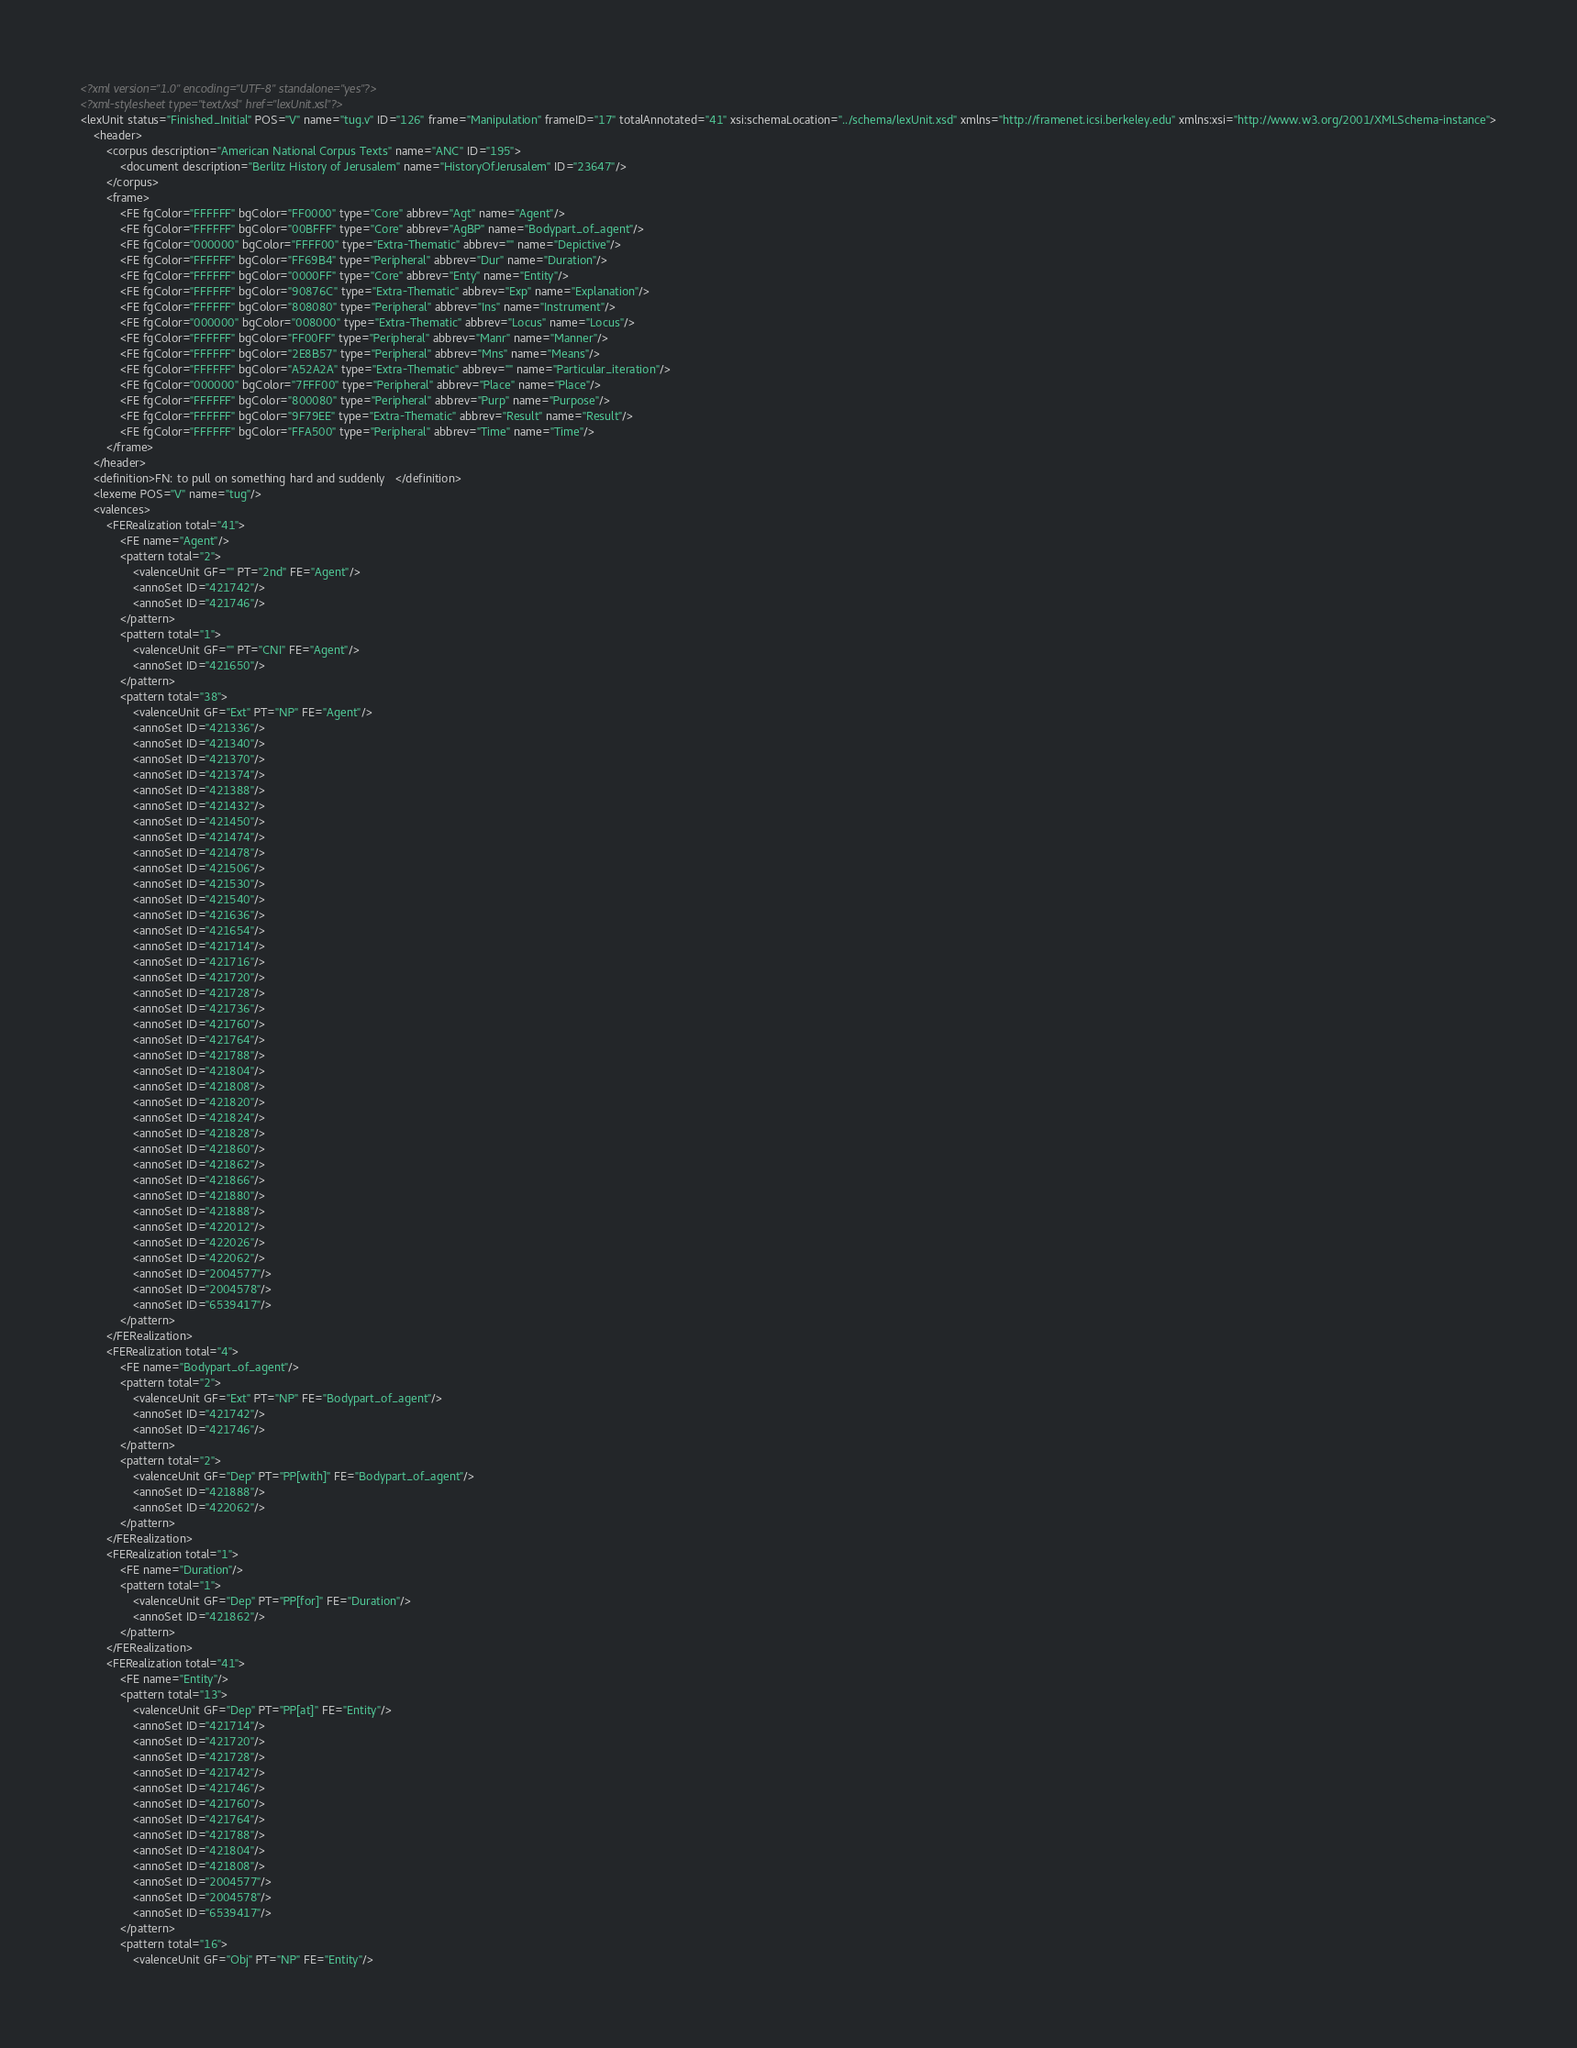Convert code to text. <code><loc_0><loc_0><loc_500><loc_500><_XML_><?xml version="1.0" encoding="UTF-8" standalone="yes"?>
<?xml-stylesheet type="text/xsl" href="lexUnit.xsl"?>
<lexUnit status="Finished_Initial" POS="V" name="tug.v" ID="126" frame="Manipulation" frameID="17" totalAnnotated="41" xsi:schemaLocation="../schema/lexUnit.xsd" xmlns="http://framenet.icsi.berkeley.edu" xmlns:xsi="http://www.w3.org/2001/XMLSchema-instance">
    <header>
        <corpus description="American National Corpus Texts" name="ANC" ID="195">
            <document description="Berlitz History of Jerusalem" name="HistoryOfJerusalem" ID="23647"/>
        </corpus>
        <frame>
            <FE fgColor="FFFFFF" bgColor="FF0000" type="Core" abbrev="Agt" name="Agent"/>
            <FE fgColor="FFFFFF" bgColor="00BFFF" type="Core" abbrev="AgBP" name="Bodypart_of_agent"/>
            <FE fgColor="000000" bgColor="FFFF00" type="Extra-Thematic" abbrev="" name="Depictive"/>
            <FE fgColor="FFFFFF" bgColor="FF69B4" type="Peripheral" abbrev="Dur" name="Duration"/>
            <FE fgColor="FFFFFF" bgColor="0000FF" type="Core" abbrev="Enty" name="Entity"/>
            <FE fgColor="FFFFFF" bgColor="90876C" type="Extra-Thematic" abbrev="Exp" name="Explanation"/>
            <FE fgColor="FFFFFF" bgColor="808080" type="Peripheral" abbrev="Ins" name="Instrument"/>
            <FE fgColor="000000" bgColor="008000" type="Extra-Thematic" abbrev="Locus" name="Locus"/>
            <FE fgColor="FFFFFF" bgColor="FF00FF" type="Peripheral" abbrev="Manr" name="Manner"/>
            <FE fgColor="FFFFFF" bgColor="2E8B57" type="Peripheral" abbrev="Mns" name="Means"/>
            <FE fgColor="FFFFFF" bgColor="A52A2A" type="Extra-Thematic" abbrev="" name="Particular_iteration"/>
            <FE fgColor="000000" bgColor="7FFF00" type="Peripheral" abbrev="Place" name="Place"/>
            <FE fgColor="FFFFFF" bgColor="800080" type="Peripheral" abbrev="Purp" name="Purpose"/>
            <FE fgColor="FFFFFF" bgColor="9F79EE" type="Extra-Thematic" abbrev="Result" name="Result"/>
            <FE fgColor="FFFFFF" bgColor="FFA500" type="Peripheral" abbrev="Time" name="Time"/>
        </frame>
    </header>
    <definition>FN: to pull on something hard and suddenly   </definition>
    <lexeme POS="V" name="tug"/>
    <valences>
        <FERealization total="41">
            <FE name="Agent"/>
            <pattern total="2">
                <valenceUnit GF="" PT="2nd" FE="Agent"/>
                <annoSet ID="421742"/>
                <annoSet ID="421746"/>
            </pattern>
            <pattern total="1">
                <valenceUnit GF="" PT="CNI" FE="Agent"/>
                <annoSet ID="421650"/>
            </pattern>
            <pattern total="38">
                <valenceUnit GF="Ext" PT="NP" FE="Agent"/>
                <annoSet ID="421336"/>
                <annoSet ID="421340"/>
                <annoSet ID="421370"/>
                <annoSet ID="421374"/>
                <annoSet ID="421388"/>
                <annoSet ID="421432"/>
                <annoSet ID="421450"/>
                <annoSet ID="421474"/>
                <annoSet ID="421478"/>
                <annoSet ID="421506"/>
                <annoSet ID="421530"/>
                <annoSet ID="421540"/>
                <annoSet ID="421636"/>
                <annoSet ID="421654"/>
                <annoSet ID="421714"/>
                <annoSet ID="421716"/>
                <annoSet ID="421720"/>
                <annoSet ID="421728"/>
                <annoSet ID="421736"/>
                <annoSet ID="421760"/>
                <annoSet ID="421764"/>
                <annoSet ID="421788"/>
                <annoSet ID="421804"/>
                <annoSet ID="421808"/>
                <annoSet ID="421820"/>
                <annoSet ID="421824"/>
                <annoSet ID="421828"/>
                <annoSet ID="421860"/>
                <annoSet ID="421862"/>
                <annoSet ID="421866"/>
                <annoSet ID="421880"/>
                <annoSet ID="421888"/>
                <annoSet ID="422012"/>
                <annoSet ID="422026"/>
                <annoSet ID="422062"/>
                <annoSet ID="2004577"/>
                <annoSet ID="2004578"/>
                <annoSet ID="6539417"/>
            </pattern>
        </FERealization>
        <FERealization total="4">
            <FE name="Bodypart_of_agent"/>
            <pattern total="2">
                <valenceUnit GF="Ext" PT="NP" FE="Bodypart_of_agent"/>
                <annoSet ID="421742"/>
                <annoSet ID="421746"/>
            </pattern>
            <pattern total="2">
                <valenceUnit GF="Dep" PT="PP[with]" FE="Bodypart_of_agent"/>
                <annoSet ID="421888"/>
                <annoSet ID="422062"/>
            </pattern>
        </FERealization>
        <FERealization total="1">
            <FE name="Duration"/>
            <pattern total="1">
                <valenceUnit GF="Dep" PT="PP[for]" FE="Duration"/>
                <annoSet ID="421862"/>
            </pattern>
        </FERealization>
        <FERealization total="41">
            <FE name="Entity"/>
            <pattern total="13">
                <valenceUnit GF="Dep" PT="PP[at]" FE="Entity"/>
                <annoSet ID="421714"/>
                <annoSet ID="421720"/>
                <annoSet ID="421728"/>
                <annoSet ID="421742"/>
                <annoSet ID="421746"/>
                <annoSet ID="421760"/>
                <annoSet ID="421764"/>
                <annoSet ID="421788"/>
                <annoSet ID="421804"/>
                <annoSet ID="421808"/>
                <annoSet ID="2004577"/>
                <annoSet ID="2004578"/>
                <annoSet ID="6539417"/>
            </pattern>
            <pattern total="16">
                <valenceUnit GF="Obj" PT="NP" FE="Entity"/></code> 